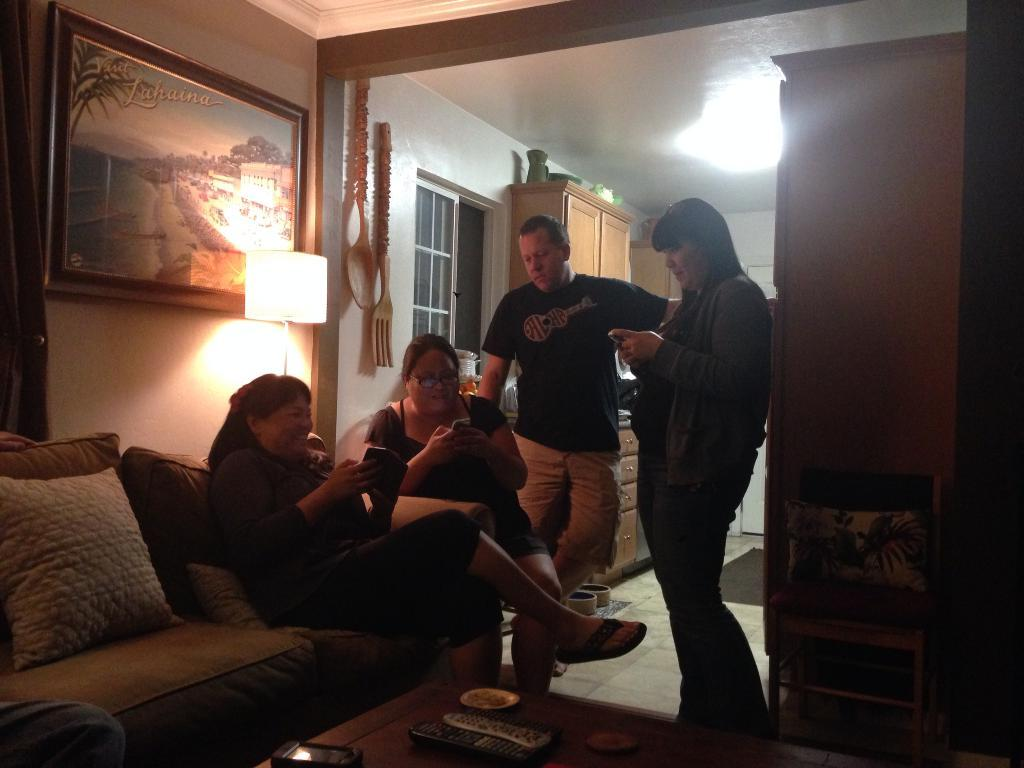What are the people in the image doing? There are people sitting on a sofa and standing in the image. What can be seen in the background of the image? There is a photo frame, a lamp, glass windows, and cupboards in the background of the image. What grade did the ghost receive in the image? There is no ghost present in the image, so it is not possible to determine any grades. 